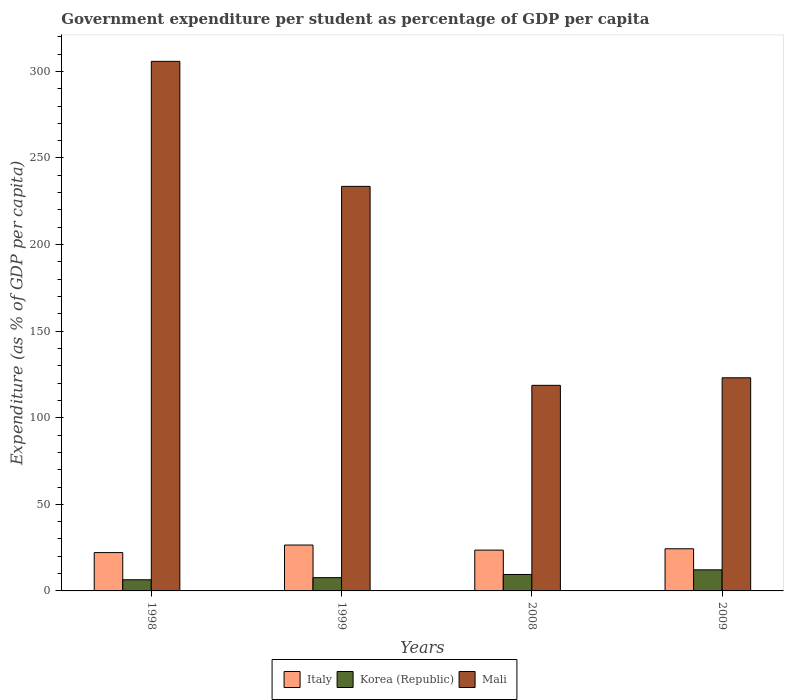How many different coloured bars are there?
Your answer should be very brief. 3. Are the number of bars per tick equal to the number of legend labels?
Keep it short and to the point. Yes. Are the number of bars on each tick of the X-axis equal?
Your answer should be compact. Yes. What is the label of the 1st group of bars from the left?
Offer a terse response. 1998. What is the percentage of expenditure per student in Korea (Republic) in 1998?
Offer a terse response. 6.44. Across all years, what is the maximum percentage of expenditure per student in Italy?
Keep it short and to the point. 26.49. Across all years, what is the minimum percentage of expenditure per student in Italy?
Offer a terse response. 22.13. In which year was the percentage of expenditure per student in Italy maximum?
Your response must be concise. 1999. What is the total percentage of expenditure per student in Mali in the graph?
Provide a short and direct response. 781.17. What is the difference between the percentage of expenditure per student in Korea (Republic) in 1998 and that in 1999?
Provide a succinct answer. -1.22. What is the difference between the percentage of expenditure per student in Italy in 1998 and the percentage of expenditure per student in Korea (Republic) in 2009?
Keep it short and to the point. 9.96. What is the average percentage of expenditure per student in Korea (Republic) per year?
Give a very brief answer. 8.94. In the year 2009, what is the difference between the percentage of expenditure per student in Italy and percentage of expenditure per student in Mali?
Offer a terse response. -98.74. What is the ratio of the percentage of expenditure per student in Italy in 2008 to that in 2009?
Your response must be concise. 0.97. Is the percentage of expenditure per student in Korea (Republic) in 1998 less than that in 1999?
Give a very brief answer. Yes. What is the difference between the highest and the second highest percentage of expenditure per student in Mali?
Keep it short and to the point. 72.19. What is the difference between the highest and the lowest percentage of expenditure per student in Korea (Republic)?
Provide a succinct answer. 5.73. In how many years, is the percentage of expenditure per student in Mali greater than the average percentage of expenditure per student in Mali taken over all years?
Make the answer very short. 2. What does the 3rd bar from the left in 2009 represents?
Your response must be concise. Mali. Is it the case that in every year, the sum of the percentage of expenditure per student in Korea (Republic) and percentage of expenditure per student in Italy is greater than the percentage of expenditure per student in Mali?
Make the answer very short. No. Are all the bars in the graph horizontal?
Provide a short and direct response. No. How many years are there in the graph?
Provide a short and direct response. 4. What is the difference between two consecutive major ticks on the Y-axis?
Offer a terse response. 50. Does the graph contain any zero values?
Your response must be concise. No. Does the graph contain grids?
Keep it short and to the point. No. How are the legend labels stacked?
Ensure brevity in your answer.  Horizontal. What is the title of the graph?
Make the answer very short. Government expenditure per student as percentage of GDP per capita. What is the label or title of the Y-axis?
Your response must be concise. Expenditure (as % of GDP per capita). What is the Expenditure (as % of GDP per capita) of Italy in 1998?
Your response must be concise. 22.13. What is the Expenditure (as % of GDP per capita) in Korea (Republic) in 1998?
Provide a short and direct response. 6.44. What is the Expenditure (as % of GDP per capita) in Mali in 1998?
Your answer should be compact. 305.79. What is the Expenditure (as % of GDP per capita) of Italy in 1999?
Offer a very short reply. 26.49. What is the Expenditure (as % of GDP per capita) of Korea (Republic) in 1999?
Make the answer very short. 7.67. What is the Expenditure (as % of GDP per capita) of Mali in 1999?
Make the answer very short. 233.6. What is the Expenditure (as % of GDP per capita) in Italy in 2008?
Give a very brief answer. 23.56. What is the Expenditure (as % of GDP per capita) in Korea (Republic) in 2008?
Ensure brevity in your answer.  9.49. What is the Expenditure (as % of GDP per capita) of Mali in 2008?
Offer a terse response. 118.71. What is the Expenditure (as % of GDP per capita) of Italy in 2009?
Provide a succinct answer. 24.33. What is the Expenditure (as % of GDP per capita) in Korea (Republic) in 2009?
Provide a succinct answer. 12.17. What is the Expenditure (as % of GDP per capita) of Mali in 2009?
Offer a terse response. 123.07. Across all years, what is the maximum Expenditure (as % of GDP per capita) in Italy?
Keep it short and to the point. 26.49. Across all years, what is the maximum Expenditure (as % of GDP per capita) in Korea (Republic)?
Give a very brief answer. 12.17. Across all years, what is the maximum Expenditure (as % of GDP per capita) in Mali?
Your answer should be very brief. 305.79. Across all years, what is the minimum Expenditure (as % of GDP per capita) in Italy?
Your response must be concise. 22.13. Across all years, what is the minimum Expenditure (as % of GDP per capita) in Korea (Republic)?
Make the answer very short. 6.44. Across all years, what is the minimum Expenditure (as % of GDP per capita) in Mali?
Provide a succinct answer. 118.71. What is the total Expenditure (as % of GDP per capita) in Italy in the graph?
Make the answer very short. 96.52. What is the total Expenditure (as % of GDP per capita) in Korea (Republic) in the graph?
Offer a very short reply. 35.77. What is the total Expenditure (as % of GDP per capita) of Mali in the graph?
Offer a terse response. 781.17. What is the difference between the Expenditure (as % of GDP per capita) of Italy in 1998 and that in 1999?
Provide a succinct answer. -4.36. What is the difference between the Expenditure (as % of GDP per capita) of Korea (Republic) in 1998 and that in 1999?
Provide a short and direct response. -1.22. What is the difference between the Expenditure (as % of GDP per capita) of Mali in 1998 and that in 1999?
Make the answer very short. 72.19. What is the difference between the Expenditure (as % of GDP per capita) of Italy in 1998 and that in 2008?
Offer a very short reply. -1.42. What is the difference between the Expenditure (as % of GDP per capita) in Korea (Republic) in 1998 and that in 2008?
Keep it short and to the point. -3.05. What is the difference between the Expenditure (as % of GDP per capita) of Mali in 1998 and that in 2008?
Provide a short and direct response. 187.08. What is the difference between the Expenditure (as % of GDP per capita) of Italy in 1998 and that in 2009?
Your response must be concise. -2.2. What is the difference between the Expenditure (as % of GDP per capita) in Korea (Republic) in 1998 and that in 2009?
Ensure brevity in your answer.  -5.73. What is the difference between the Expenditure (as % of GDP per capita) in Mali in 1998 and that in 2009?
Give a very brief answer. 182.72. What is the difference between the Expenditure (as % of GDP per capita) in Italy in 1999 and that in 2008?
Make the answer very short. 2.93. What is the difference between the Expenditure (as % of GDP per capita) in Korea (Republic) in 1999 and that in 2008?
Provide a succinct answer. -1.83. What is the difference between the Expenditure (as % of GDP per capita) in Mali in 1999 and that in 2008?
Offer a very short reply. 114.89. What is the difference between the Expenditure (as % of GDP per capita) in Italy in 1999 and that in 2009?
Your answer should be compact. 2.16. What is the difference between the Expenditure (as % of GDP per capita) in Korea (Republic) in 1999 and that in 2009?
Make the answer very short. -4.51. What is the difference between the Expenditure (as % of GDP per capita) of Mali in 1999 and that in 2009?
Your answer should be very brief. 110.53. What is the difference between the Expenditure (as % of GDP per capita) in Italy in 2008 and that in 2009?
Keep it short and to the point. -0.78. What is the difference between the Expenditure (as % of GDP per capita) of Korea (Republic) in 2008 and that in 2009?
Provide a short and direct response. -2.68. What is the difference between the Expenditure (as % of GDP per capita) of Mali in 2008 and that in 2009?
Keep it short and to the point. -4.36. What is the difference between the Expenditure (as % of GDP per capita) of Italy in 1998 and the Expenditure (as % of GDP per capita) of Korea (Republic) in 1999?
Offer a very short reply. 14.47. What is the difference between the Expenditure (as % of GDP per capita) in Italy in 1998 and the Expenditure (as % of GDP per capita) in Mali in 1999?
Offer a very short reply. -211.47. What is the difference between the Expenditure (as % of GDP per capita) of Korea (Republic) in 1998 and the Expenditure (as % of GDP per capita) of Mali in 1999?
Give a very brief answer. -227.16. What is the difference between the Expenditure (as % of GDP per capita) of Italy in 1998 and the Expenditure (as % of GDP per capita) of Korea (Republic) in 2008?
Your answer should be compact. 12.64. What is the difference between the Expenditure (as % of GDP per capita) of Italy in 1998 and the Expenditure (as % of GDP per capita) of Mali in 2008?
Your answer should be compact. -96.58. What is the difference between the Expenditure (as % of GDP per capita) in Korea (Republic) in 1998 and the Expenditure (as % of GDP per capita) in Mali in 2008?
Your answer should be compact. -112.27. What is the difference between the Expenditure (as % of GDP per capita) of Italy in 1998 and the Expenditure (as % of GDP per capita) of Korea (Republic) in 2009?
Your answer should be very brief. 9.96. What is the difference between the Expenditure (as % of GDP per capita) of Italy in 1998 and the Expenditure (as % of GDP per capita) of Mali in 2009?
Offer a terse response. -100.94. What is the difference between the Expenditure (as % of GDP per capita) of Korea (Republic) in 1998 and the Expenditure (as % of GDP per capita) of Mali in 2009?
Your response must be concise. -116.63. What is the difference between the Expenditure (as % of GDP per capita) in Italy in 1999 and the Expenditure (as % of GDP per capita) in Korea (Republic) in 2008?
Keep it short and to the point. 17. What is the difference between the Expenditure (as % of GDP per capita) of Italy in 1999 and the Expenditure (as % of GDP per capita) of Mali in 2008?
Your response must be concise. -92.22. What is the difference between the Expenditure (as % of GDP per capita) in Korea (Republic) in 1999 and the Expenditure (as % of GDP per capita) in Mali in 2008?
Your answer should be compact. -111.05. What is the difference between the Expenditure (as % of GDP per capita) in Italy in 1999 and the Expenditure (as % of GDP per capita) in Korea (Republic) in 2009?
Ensure brevity in your answer.  14.32. What is the difference between the Expenditure (as % of GDP per capita) of Italy in 1999 and the Expenditure (as % of GDP per capita) of Mali in 2009?
Provide a short and direct response. -96.58. What is the difference between the Expenditure (as % of GDP per capita) in Korea (Republic) in 1999 and the Expenditure (as % of GDP per capita) in Mali in 2009?
Give a very brief answer. -115.41. What is the difference between the Expenditure (as % of GDP per capita) of Italy in 2008 and the Expenditure (as % of GDP per capita) of Korea (Republic) in 2009?
Provide a succinct answer. 11.39. What is the difference between the Expenditure (as % of GDP per capita) in Italy in 2008 and the Expenditure (as % of GDP per capita) in Mali in 2009?
Provide a succinct answer. -99.52. What is the difference between the Expenditure (as % of GDP per capita) of Korea (Republic) in 2008 and the Expenditure (as % of GDP per capita) of Mali in 2009?
Provide a succinct answer. -113.58. What is the average Expenditure (as % of GDP per capita) in Italy per year?
Make the answer very short. 24.13. What is the average Expenditure (as % of GDP per capita) in Korea (Republic) per year?
Your answer should be compact. 8.94. What is the average Expenditure (as % of GDP per capita) of Mali per year?
Your response must be concise. 195.29. In the year 1998, what is the difference between the Expenditure (as % of GDP per capita) in Italy and Expenditure (as % of GDP per capita) in Korea (Republic)?
Offer a terse response. 15.69. In the year 1998, what is the difference between the Expenditure (as % of GDP per capita) in Italy and Expenditure (as % of GDP per capita) in Mali?
Keep it short and to the point. -283.65. In the year 1998, what is the difference between the Expenditure (as % of GDP per capita) in Korea (Republic) and Expenditure (as % of GDP per capita) in Mali?
Ensure brevity in your answer.  -299.35. In the year 1999, what is the difference between the Expenditure (as % of GDP per capita) in Italy and Expenditure (as % of GDP per capita) in Korea (Republic)?
Offer a very short reply. 18.82. In the year 1999, what is the difference between the Expenditure (as % of GDP per capita) in Italy and Expenditure (as % of GDP per capita) in Mali?
Provide a short and direct response. -207.11. In the year 1999, what is the difference between the Expenditure (as % of GDP per capita) of Korea (Republic) and Expenditure (as % of GDP per capita) of Mali?
Provide a short and direct response. -225.93. In the year 2008, what is the difference between the Expenditure (as % of GDP per capita) in Italy and Expenditure (as % of GDP per capita) in Korea (Republic)?
Provide a succinct answer. 14.06. In the year 2008, what is the difference between the Expenditure (as % of GDP per capita) of Italy and Expenditure (as % of GDP per capita) of Mali?
Your response must be concise. -95.15. In the year 2008, what is the difference between the Expenditure (as % of GDP per capita) in Korea (Republic) and Expenditure (as % of GDP per capita) in Mali?
Make the answer very short. -109.22. In the year 2009, what is the difference between the Expenditure (as % of GDP per capita) of Italy and Expenditure (as % of GDP per capita) of Korea (Republic)?
Your answer should be very brief. 12.16. In the year 2009, what is the difference between the Expenditure (as % of GDP per capita) in Italy and Expenditure (as % of GDP per capita) in Mali?
Your answer should be very brief. -98.74. In the year 2009, what is the difference between the Expenditure (as % of GDP per capita) of Korea (Republic) and Expenditure (as % of GDP per capita) of Mali?
Make the answer very short. -110.9. What is the ratio of the Expenditure (as % of GDP per capita) in Italy in 1998 to that in 1999?
Provide a short and direct response. 0.84. What is the ratio of the Expenditure (as % of GDP per capita) of Korea (Republic) in 1998 to that in 1999?
Provide a short and direct response. 0.84. What is the ratio of the Expenditure (as % of GDP per capita) of Mali in 1998 to that in 1999?
Your answer should be very brief. 1.31. What is the ratio of the Expenditure (as % of GDP per capita) in Italy in 1998 to that in 2008?
Your answer should be compact. 0.94. What is the ratio of the Expenditure (as % of GDP per capita) of Korea (Republic) in 1998 to that in 2008?
Your answer should be compact. 0.68. What is the ratio of the Expenditure (as % of GDP per capita) of Mali in 1998 to that in 2008?
Offer a very short reply. 2.58. What is the ratio of the Expenditure (as % of GDP per capita) in Italy in 1998 to that in 2009?
Give a very brief answer. 0.91. What is the ratio of the Expenditure (as % of GDP per capita) in Korea (Republic) in 1998 to that in 2009?
Offer a very short reply. 0.53. What is the ratio of the Expenditure (as % of GDP per capita) in Mali in 1998 to that in 2009?
Keep it short and to the point. 2.48. What is the ratio of the Expenditure (as % of GDP per capita) of Italy in 1999 to that in 2008?
Give a very brief answer. 1.12. What is the ratio of the Expenditure (as % of GDP per capita) in Korea (Republic) in 1999 to that in 2008?
Keep it short and to the point. 0.81. What is the ratio of the Expenditure (as % of GDP per capita) of Mali in 1999 to that in 2008?
Offer a terse response. 1.97. What is the ratio of the Expenditure (as % of GDP per capita) in Italy in 1999 to that in 2009?
Give a very brief answer. 1.09. What is the ratio of the Expenditure (as % of GDP per capita) in Korea (Republic) in 1999 to that in 2009?
Your response must be concise. 0.63. What is the ratio of the Expenditure (as % of GDP per capita) in Mali in 1999 to that in 2009?
Offer a very short reply. 1.9. What is the ratio of the Expenditure (as % of GDP per capita) in Italy in 2008 to that in 2009?
Your answer should be very brief. 0.97. What is the ratio of the Expenditure (as % of GDP per capita) of Korea (Republic) in 2008 to that in 2009?
Ensure brevity in your answer.  0.78. What is the ratio of the Expenditure (as % of GDP per capita) of Mali in 2008 to that in 2009?
Provide a short and direct response. 0.96. What is the difference between the highest and the second highest Expenditure (as % of GDP per capita) in Italy?
Keep it short and to the point. 2.16. What is the difference between the highest and the second highest Expenditure (as % of GDP per capita) of Korea (Republic)?
Make the answer very short. 2.68. What is the difference between the highest and the second highest Expenditure (as % of GDP per capita) of Mali?
Your response must be concise. 72.19. What is the difference between the highest and the lowest Expenditure (as % of GDP per capita) of Italy?
Make the answer very short. 4.36. What is the difference between the highest and the lowest Expenditure (as % of GDP per capita) in Korea (Republic)?
Make the answer very short. 5.73. What is the difference between the highest and the lowest Expenditure (as % of GDP per capita) in Mali?
Make the answer very short. 187.08. 